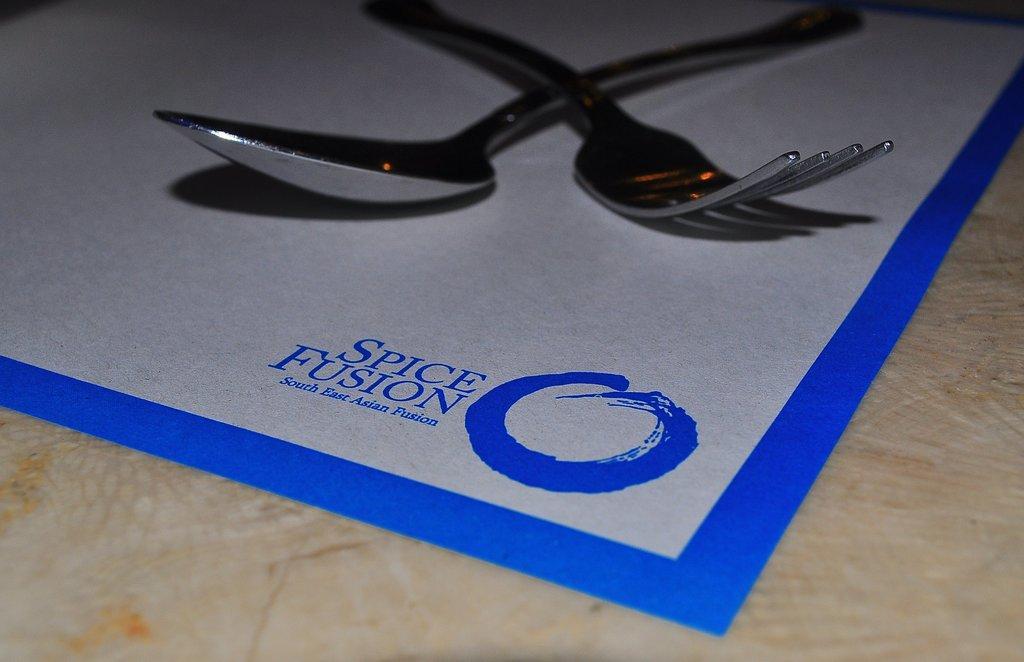Describe this image in one or two sentences. Here I can see a spoon and a fork on a white color sheet which is placed on a table. On this sheet I can see some text in blue color. 